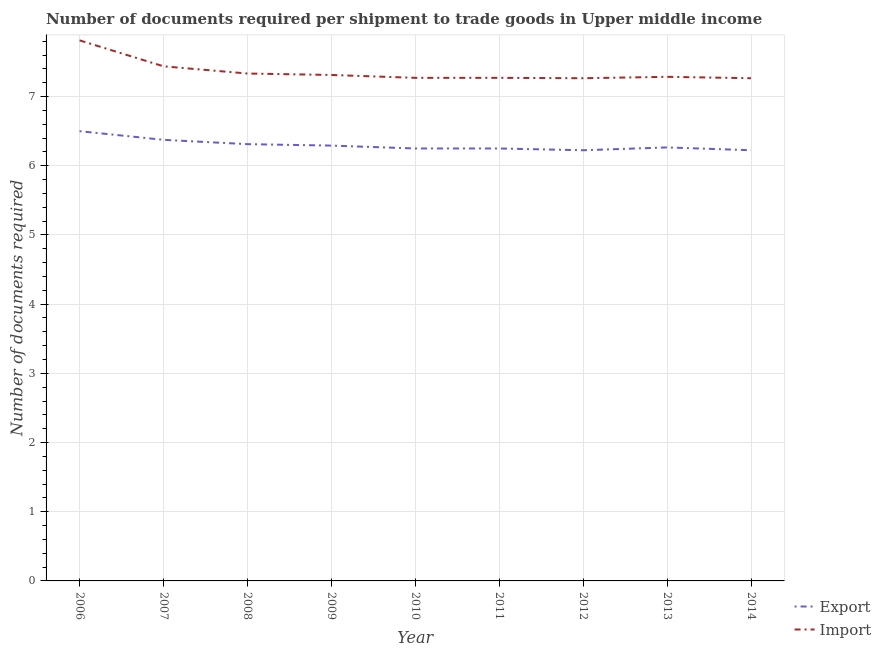How many different coloured lines are there?
Provide a succinct answer. 2. What is the number of documents required to export goods in 2007?
Make the answer very short. 6.38. Across all years, what is the minimum number of documents required to export goods?
Give a very brief answer. 6.22. What is the total number of documents required to import goods in the graph?
Your response must be concise. 66.25. What is the difference between the number of documents required to import goods in 2010 and the number of documents required to export goods in 2011?
Provide a short and direct response. 1.02. What is the average number of documents required to export goods per year?
Your response must be concise. 6.3. In the year 2008, what is the difference between the number of documents required to import goods and number of documents required to export goods?
Offer a terse response. 1.02. In how many years, is the number of documents required to import goods greater than 5.2?
Your answer should be very brief. 9. What is the ratio of the number of documents required to export goods in 2009 to that in 2011?
Keep it short and to the point. 1.01. Is the difference between the number of documents required to export goods in 2007 and 2012 greater than the difference between the number of documents required to import goods in 2007 and 2012?
Your answer should be very brief. No. What is the difference between the highest and the lowest number of documents required to export goods?
Make the answer very short. 0.28. In how many years, is the number of documents required to export goods greater than the average number of documents required to export goods taken over all years?
Offer a very short reply. 3. Does the number of documents required to export goods monotonically increase over the years?
Provide a succinct answer. No. Is the number of documents required to export goods strictly greater than the number of documents required to import goods over the years?
Offer a very short reply. No. Is the number of documents required to import goods strictly less than the number of documents required to export goods over the years?
Your answer should be compact. No. How many lines are there?
Provide a short and direct response. 2. Are the values on the major ticks of Y-axis written in scientific E-notation?
Your response must be concise. No. Where does the legend appear in the graph?
Provide a short and direct response. Bottom right. How many legend labels are there?
Give a very brief answer. 2. How are the legend labels stacked?
Make the answer very short. Vertical. What is the title of the graph?
Ensure brevity in your answer.  Number of documents required per shipment to trade goods in Upper middle income. Does "Exports of goods" appear as one of the legend labels in the graph?
Your answer should be very brief. No. What is the label or title of the X-axis?
Your response must be concise. Year. What is the label or title of the Y-axis?
Your answer should be very brief. Number of documents required. What is the Number of documents required in Import in 2006?
Offer a very short reply. 7.81. What is the Number of documents required in Export in 2007?
Ensure brevity in your answer.  6.38. What is the Number of documents required in Import in 2007?
Ensure brevity in your answer.  7.44. What is the Number of documents required in Export in 2008?
Offer a terse response. 6.31. What is the Number of documents required in Import in 2008?
Ensure brevity in your answer.  7.33. What is the Number of documents required of Export in 2009?
Ensure brevity in your answer.  6.29. What is the Number of documents required in Import in 2009?
Make the answer very short. 7.31. What is the Number of documents required of Export in 2010?
Ensure brevity in your answer.  6.25. What is the Number of documents required of Import in 2010?
Provide a succinct answer. 7.27. What is the Number of documents required in Export in 2011?
Your answer should be very brief. 6.25. What is the Number of documents required in Import in 2011?
Your answer should be very brief. 7.27. What is the Number of documents required of Export in 2012?
Provide a succinct answer. 6.22. What is the Number of documents required of Import in 2012?
Provide a short and direct response. 7.27. What is the Number of documents required in Export in 2013?
Provide a succinct answer. 6.27. What is the Number of documents required in Import in 2013?
Your answer should be very brief. 7.29. What is the Number of documents required in Export in 2014?
Offer a terse response. 6.22. What is the Number of documents required of Import in 2014?
Ensure brevity in your answer.  7.27. Across all years, what is the maximum Number of documents required in Export?
Your answer should be compact. 6.5. Across all years, what is the maximum Number of documents required of Import?
Give a very brief answer. 7.81. Across all years, what is the minimum Number of documents required of Export?
Provide a short and direct response. 6.22. Across all years, what is the minimum Number of documents required of Import?
Keep it short and to the point. 7.27. What is the total Number of documents required of Export in the graph?
Make the answer very short. 56.69. What is the total Number of documents required in Import in the graph?
Provide a short and direct response. 66.25. What is the difference between the Number of documents required in Export in 2006 and that in 2007?
Give a very brief answer. 0.12. What is the difference between the Number of documents required of Export in 2006 and that in 2008?
Your response must be concise. 0.19. What is the difference between the Number of documents required of Import in 2006 and that in 2008?
Your answer should be very brief. 0.48. What is the difference between the Number of documents required of Export in 2006 and that in 2009?
Your answer should be very brief. 0.21. What is the difference between the Number of documents required of Import in 2006 and that in 2009?
Provide a short and direct response. 0.5. What is the difference between the Number of documents required in Export in 2006 and that in 2010?
Provide a short and direct response. 0.25. What is the difference between the Number of documents required of Import in 2006 and that in 2010?
Offer a very short reply. 0.54. What is the difference between the Number of documents required in Export in 2006 and that in 2011?
Offer a very short reply. 0.25. What is the difference between the Number of documents required of Import in 2006 and that in 2011?
Ensure brevity in your answer.  0.54. What is the difference between the Number of documents required of Export in 2006 and that in 2012?
Your response must be concise. 0.28. What is the difference between the Number of documents required in Import in 2006 and that in 2012?
Offer a very short reply. 0.55. What is the difference between the Number of documents required in Export in 2006 and that in 2013?
Provide a succinct answer. 0.23. What is the difference between the Number of documents required in Import in 2006 and that in 2013?
Your answer should be compact. 0.53. What is the difference between the Number of documents required in Export in 2006 and that in 2014?
Your answer should be compact. 0.28. What is the difference between the Number of documents required in Import in 2006 and that in 2014?
Offer a terse response. 0.55. What is the difference between the Number of documents required of Export in 2007 and that in 2008?
Your response must be concise. 0.06. What is the difference between the Number of documents required in Import in 2007 and that in 2008?
Offer a terse response. 0.1. What is the difference between the Number of documents required in Export in 2007 and that in 2009?
Offer a very short reply. 0.08. What is the difference between the Number of documents required in Export in 2007 and that in 2010?
Offer a very short reply. 0.12. What is the difference between the Number of documents required in Import in 2007 and that in 2010?
Offer a terse response. 0.17. What is the difference between the Number of documents required in Import in 2007 and that in 2011?
Offer a terse response. 0.17. What is the difference between the Number of documents required in Export in 2007 and that in 2012?
Make the answer very short. 0.15. What is the difference between the Number of documents required of Import in 2007 and that in 2012?
Offer a very short reply. 0.17. What is the difference between the Number of documents required of Export in 2007 and that in 2013?
Your response must be concise. 0.11. What is the difference between the Number of documents required in Import in 2007 and that in 2013?
Offer a terse response. 0.15. What is the difference between the Number of documents required of Export in 2007 and that in 2014?
Your response must be concise. 0.15. What is the difference between the Number of documents required of Import in 2007 and that in 2014?
Offer a very short reply. 0.17. What is the difference between the Number of documents required of Export in 2008 and that in 2009?
Provide a succinct answer. 0.02. What is the difference between the Number of documents required in Import in 2008 and that in 2009?
Offer a terse response. 0.02. What is the difference between the Number of documents required in Export in 2008 and that in 2010?
Your answer should be compact. 0.06. What is the difference between the Number of documents required of Import in 2008 and that in 2010?
Make the answer very short. 0.06. What is the difference between the Number of documents required of Export in 2008 and that in 2011?
Offer a very short reply. 0.06. What is the difference between the Number of documents required of Import in 2008 and that in 2011?
Offer a very short reply. 0.06. What is the difference between the Number of documents required in Export in 2008 and that in 2012?
Make the answer very short. 0.09. What is the difference between the Number of documents required of Import in 2008 and that in 2012?
Provide a succinct answer. 0.07. What is the difference between the Number of documents required of Export in 2008 and that in 2013?
Provide a short and direct response. 0.05. What is the difference between the Number of documents required in Import in 2008 and that in 2013?
Give a very brief answer. 0.05. What is the difference between the Number of documents required in Export in 2008 and that in 2014?
Your answer should be compact. 0.09. What is the difference between the Number of documents required in Import in 2008 and that in 2014?
Your response must be concise. 0.07. What is the difference between the Number of documents required of Export in 2009 and that in 2010?
Give a very brief answer. 0.04. What is the difference between the Number of documents required in Import in 2009 and that in 2010?
Your answer should be compact. 0.04. What is the difference between the Number of documents required in Export in 2009 and that in 2011?
Your answer should be compact. 0.04. What is the difference between the Number of documents required in Import in 2009 and that in 2011?
Your answer should be very brief. 0.04. What is the difference between the Number of documents required of Export in 2009 and that in 2012?
Offer a very short reply. 0.07. What is the difference between the Number of documents required of Import in 2009 and that in 2012?
Keep it short and to the point. 0.05. What is the difference between the Number of documents required in Export in 2009 and that in 2013?
Give a very brief answer. 0.03. What is the difference between the Number of documents required in Import in 2009 and that in 2013?
Your answer should be very brief. 0.03. What is the difference between the Number of documents required in Export in 2009 and that in 2014?
Make the answer very short. 0.07. What is the difference between the Number of documents required of Import in 2009 and that in 2014?
Your answer should be compact. 0.05. What is the difference between the Number of documents required in Import in 2010 and that in 2011?
Your answer should be compact. 0. What is the difference between the Number of documents required in Export in 2010 and that in 2012?
Keep it short and to the point. 0.03. What is the difference between the Number of documents required of Import in 2010 and that in 2012?
Offer a terse response. 0.01. What is the difference between the Number of documents required in Export in 2010 and that in 2013?
Provide a succinct answer. -0.02. What is the difference between the Number of documents required of Import in 2010 and that in 2013?
Make the answer very short. -0.01. What is the difference between the Number of documents required in Export in 2010 and that in 2014?
Make the answer very short. 0.03. What is the difference between the Number of documents required of Import in 2010 and that in 2014?
Provide a short and direct response. 0.01. What is the difference between the Number of documents required in Export in 2011 and that in 2012?
Offer a very short reply. 0.03. What is the difference between the Number of documents required in Import in 2011 and that in 2012?
Give a very brief answer. 0.01. What is the difference between the Number of documents required of Export in 2011 and that in 2013?
Offer a very short reply. -0.02. What is the difference between the Number of documents required in Import in 2011 and that in 2013?
Ensure brevity in your answer.  -0.01. What is the difference between the Number of documents required of Export in 2011 and that in 2014?
Keep it short and to the point. 0.03. What is the difference between the Number of documents required in Import in 2011 and that in 2014?
Your response must be concise. 0.01. What is the difference between the Number of documents required in Export in 2012 and that in 2013?
Give a very brief answer. -0.04. What is the difference between the Number of documents required of Import in 2012 and that in 2013?
Offer a very short reply. -0.02. What is the difference between the Number of documents required in Export in 2012 and that in 2014?
Your response must be concise. 0. What is the difference between the Number of documents required in Export in 2013 and that in 2014?
Give a very brief answer. 0.04. What is the difference between the Number of documents required in Import in 2013 and that in 2014?
Give a very brief answer. 0.02. What is the difference between the Number of documents required of Export in 2006 and the Number of documents required of Import in 2007?
Make the answer very short. -0.94. What is the difference between the Number of documents required in Export in 2006 and the Number of documents required in Import in 2008?
Your response must be concise. -0.83. What is the difference between the Number of documents required of Export in 2006 and the Number of documents required of Import in 2009?
Your answer should be compact. -0.81. What is the difference between the Number of documents required in Export in 2006 and the Number of documents required in Import in 2010?
Give a very brief answer. -0.77. What is the difference between the Number of documents required in Export in 2006 and the Number of documents required in Import in 2011?
Ensure brevity in your answer.  -0.77. What is the difference between the Number of documents required in Export in 2006 and the Number of documents required in Import in 2012?
Ensure brevity in your answer.  -0.77. What is the difference between the Number of documents required of Export in 2006 and the Number of documents required of Import in 2013?
Provide a succinct answer. -0.79. What is the difference between the Number of documents required of Export in 2006 and the Number of documents required of Import in 2014?
Your response must be concise. -0.77. What is the difference between the Number of documents required of Export in 2007 and the Number of documents required of Import in 2008?
Your response must be concise. -0.96. What is the difference between the Number of documents required in Export in 2007 and the Number of documents required in Import in 2009?
Make the answer very short. -0.94. What is the difference between the Number of documents required in Export in 2007 and the Number of documents required in Import in 2010?
Provide a succinct answer. -0.9. What is the difference between the Number of documents required in Export in 2007 and the Number of documents required in Import in 2011?
Provide a succinct answer. -0.9. What is the difference between the Number of documents required in Export in 2007 and the Number of documents required in Import in 2012?
Make the answer very short. -0.89. What is the difference between the Number of documents required in Export in 2007 and the Number of documents required in Import in 2013?
Ensure brevity in your answer.  -0.91. What is the difference between the Number of documents required in Export in 2007 and the Number of documents required in Import in 2014?
Offer a terse response. -0.89. What is the difference between the Number of documents required of Export in 2008 and the Number of documents required of Import in 2009?
Offer a terse response. -1. What is the difference between the Number of documents required in Export in 2008 and the Number of documents required in Import in 2010?
Your answer should be very brief. -0.96. What is the difference between the Number of documents required in Export in 2008 and the Number of documents required in Import in 2011?
Offer a very short reply. -0.96. What is the difference between the Number of documents required of Export in 2008 and the Number of documents required of Import in 2012?
Offer a very short reply. -0.95. What is the difference between the Number of documents required in Export in 2008 and the Number of documents required in Import in 2013?
Keep it short and to the point. -0.97. What is the difference between the Number of documents required of Export in 2008 and the Number of documents required of Import in 2014?
Make the answer very short. -0.95. What is the difference between the Number of documents required of Export in 2009 and the Number of documents required of Import in 2010?
Offer a terse response. -0.98. What is the difference between the Number of documents required of Export in 2009 and the Number of documents required of Import in 2011?
Offer a very short reply. -0.98. What is the difference between the Number of documents required in Export in 2009 and the Number of documents required in Import in 2012?
Provide a succinct answer. -0.97. What is the difference between the Number of documents required of Export in 2009 and the Number of documents required of Import in 2013?
Provide a short and direct response. -0.99. What is the difference between the Number of documents required in Export in 2009 and the Number of documents required in Import in 2014?
Ensure brevity in your answer.  -0.97. What is the difference between the Number of documents required in Export in 2010 and the Number of documents required in Import in 2011?
Ensure brevity in your answer.  -1.02. What is the difference between the Number of documents required of Export in 2010 and the Number of documents required of Import in 2012?
Offer a very short reply. -1.02. What is the difference between the Number of documents required of Export in 2010 and the Number of documents required of Import in 2013?
Offer a very short reply. -1.04. What is the difference between the Number of documents required in Export in 2010 and the Number of documents required in Import in 2014?
Offer a very short reply. -1.02. What is the difference between the Number of documents required of Export in 2011 and the Number of documents required of Import in 2012?
Offer a very short reply. -1.02. What is the difference between the Number of documents required of Export in 2011 and the Number of documents required of Import in 2013?
Make the answer very short. -1.04. What is the difference between the Number of documents required of Export in 2011 and the Number of documents required of Import in 2014?
Your response must be concise. -1.02. What is the difference between the Number of documents required of Export in 2012 and the Number of documents required of Import in 2013?
Your answer should be very brief. -1.06. What is the difference between the Number of documents required of Export in 2012 and the Number of documents required of Import in 2014?
Your answer should be compact. -1.04. What is the difference between the Number of documents required of Export in 2013 and the Number of documents required of Import in 2014?
Your answer should be compact. -1. What is the average Number of documents required in Export per year?
Give a very brief answer. 6.3. What is the average Number of documents required of Import per year?
Ensure brevity in your answer.  7.36. In the year 2006, what is the difference between the Number of documents required of Export and Number of documents required of Import?
Provide a succinct answer. -1.31. In the year 2007, what is the difference between the Number of documents required of Export and Number of documents required of Import?
Your answer should be very brief. -1.06. In the year 2008, what is the difference between the Number of documents required in Export and Number of documents required in Import?
Your answer should be compact. -1.02. In the year 2009, what is the difference between the Number of documents required of Export and Number of documents required of Import?
Offer a terse response. -1.02. In the year 2010, what is the difference between the Number of documents required in Export and Number of documents required in Import?
Provide a short and direct response. -1.02. In the year 2011, what is the difference between the Number of documents required in Export and Number of documents required in Import?
Your response must be concise. -1.02. In the year 2012, what is the difference between the Number of documents required of Export and Number of documents required of Import?
Offer a very short reply. -1.04. In the year 2013, what is the difference between the Number of documents required of Export and Number of documents required of Import?
Provide a short and direct response. -1.02. In the year 2014, what is the difference between the Number of documents required in Export and Number of documents required in Import?
Your answer should be very brief. -1.04. What is the ratio of the Number of documents required in Export in 2006 to that in 2007?
Ensure brevity in your answer.  1.02. What is the ratio of the Number of documents required of Import in 2006 to that in 2007?
Ensure brevity in your answer.  1.05. What is the ratio of the Number of documents required of Export in 2006 to that in 2008?
Ensure brevity in your answer.  1.03. What is the ratio of the Number of documents required of Import in 2006 to that in 2008?
Offer a very short reply. 1.07. What is the ratio of the Number of documents required of Export in 2006 to that in 2009?
Offer a terse response. 1.03. What is the ratio of the Number of documents required in Import in 2006 to that in 2009?
Make the answer very short. 1.07. What is the ratio of the Number of documents required of Import in 2006 to that in 2010?
Ensure brevity in your answer.  1.07. What is the ratio of the Number of documents required of Export in 2006 to that in 2011?
Give a very brief answer. 1.04. What is the ratio of the Number of documents required of Import in 2006 to that in 2011?
Your answer should be very brief. 1.07. What is the ratio of the Number of documents required of Export in 2006 to that in 2012?
Give a very brief answer. 1.04. What is the ratio of the Number of documents required of Import in 2006 to that in 2012?
Provide a succinct answer. 1.08. What is the ratio of the Number of documents required of Export in 2006 to that in 2013?
Provide a short and direct response. 1.04. What is the ratio of the Number of documents required in Import in 2006 to that in 2013?
Your answer should be compact. 1.07. What is the ratio of the Number of documents required in Export in 2006 to that in 2014?
Provide a succinct answer. 1.04. What is the ratio of the Number of documents required in Import in 2006 to that in 2014?
Make the answer very short. 1.08. What is the ratio of the Number of documents required in Export in 2007 to that in 2008?
Your answer should be compact. 1.01. What is the ratio of the Number of documents required in Import in 2007 to that in 2008?
Ensure brevity in your answer.  1.01. What is the ratio of the Number of documents required in Export in 2007 to that in 2009?
Offer a terse response. 1.01. What is the ratio of the Number of documents required of Import in 2007 to that in 2009?
Provide a short and direct response. 1.02. What is the ratio of the Number of documents required of Export in 2007 to that in 2010?
Offer a very short reply. 1.02. What is the ratio of the Number of documents required in Import in 2007 to that in 2010?
Your answer should be compact. 1.02. What is the ratio of the Number of documents required of Import in 2007 to that in 2011?
Give a very brief answer. 1.02. What is the ratio of the Number of documents required in Export in 2007 to that in 2012?
Give a very brief answer. 1.02. What is the ratio of the Number of documents required of Import in 2007 to that in 2012?
Your answer should be compact. 1.02. What is the ratio of the Number of documents required of Export in 2007 to that in 2013?
Offer a terse response. 1.02. What is the ratio of the Number of documents required in Import in 2007 to that in 2013?
Make the answer very short. 1.02. What is the ratio of the Number of documents required of Export in 2007 to that in 2014?
Your response must be concise. 1.02. What is the ratio of the Number of documents required in Import in 2007 to that in 2014?
Ensure brevity in your answer.  1.02. What is the ratio of the Number of documents required of Import in 2008 to that in 2009?
Make the answer very short. 1. What is the ratio of the Number of documents required in Import in 2008 to that in 2010?
Provide a succinct answer. 1.01. What is the ratio of the Number of documents required in Export in 2008 to that in 2011?
Give a very brief answer. 1.01. What is the ratio of the Number of documents required of Import in 2008 to that in 2011?
Make the answer very short. 1.01. What is the ratio of the Number of documents required in Export in 2008 to that in 2012?
Ensure brevity in your answer.  1.01. What is the ratio of the Number of documents required of Import in 2008 to that in 2012?
Your answer should be very brief. 1.01. What is the ratio of the Number of documents required of Export in 2008 to that in 2013?
Give a very brief answer. 1.01. What is the ratio of the Number of documents required of Export in 2008 to that in 2014?
Keep it short and to the point. 1.01. What is the ratio of the Number of documents required of Import in 2008 to that in 2014?
Your response must be concise. 1.01. What is the ratio of the Number of documents required in Export in 2009 to that in 2011?
Provide a succinct answer. 1.01. What is the ratio of the Number of documents required of Import in 2009 to that in 2011?
Provide a short and direct response. 1.01. What is the ratio of the Number of documents required of Export in 2009 to that in 2012?
Your answer should be very brief. 1.01. What is the ratio of the Number of documents required in Export in 2009 to that in 2013?
Provide a short and direct response. 1. What is the ratio of the Number of documents required in Import in 2009 to that in 2013?
Ensure brevity in your answer.  1. What is the ratio of the Number of documents required in Export in 2009 to that in 2014?
Your response must be concise. 1.01. What is the ratio of the Number of documents required of Export in 2010 to that in 2011?
Ensure brevity in your answer.  1. What is the ratio of the Number of documents required of Export in 2010 to that in 2012?
Your answer should be very brief. 1. What is the ratio of the Number of documents required in Import in 2010 to that in 2012?
Your answer should be compact. 1. What is the ratio of the Number of documents required of Import in 2010 to that in 2013?
Give a very brief answer. 1. What is the ratio of the Number of documents required of Export in 2011 to that in 2013?
Your response must be concise. 1. What is the ratio of the Number of documents required of Import in 2011 to that in 2013?
Your response must be concise. 1. What is the ratio of the Number of documents required of Export in 2012 to that in 2013?
Your response must be concise. 0.99. What is the ratio of the Number of documents required of Export in 2012 to that in 2014?
Your answer should be very brief. 1. What is the ratio of the Number of documents required of Import in 2012 to that in 2014?
Give a very brief answer. 1. What is the ratio of the Number of documents required of Export in 2013 to that in 2014?
Your response must be concise. 1.01. What is the ratio of the Number of documents required in Import in 2013 to that in 2014?
Provide a short and direct response. 1. What is the difference between the highest and the second highest Number of documents required in Export?
Make the answer very short. 0.12. What is the difference between the highest and the lowest Number of documents required in Export?
Make the answer very short. 0.28. What is the difference between the highest and the lowest Number of documents required in Import?
Keep it short and to the point. 0.55. 